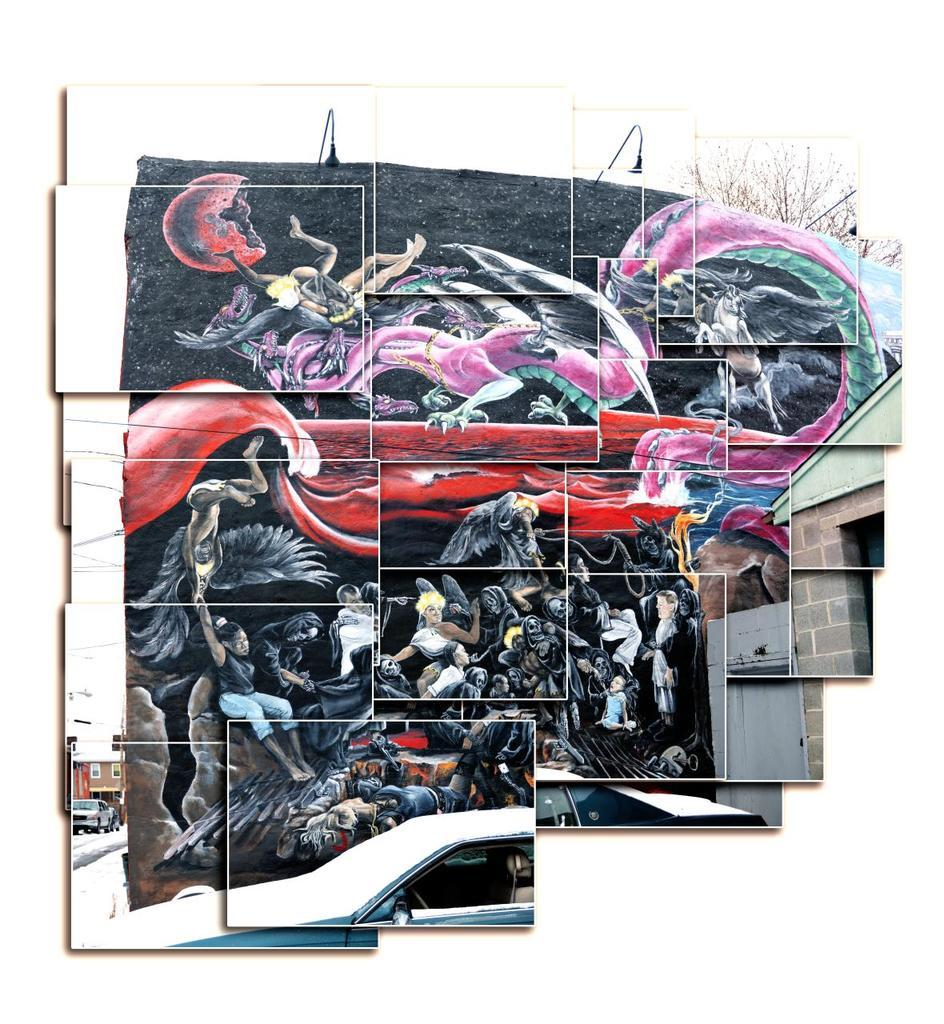What type of puzzle is depicted in the image? The image is a painting puzzle. What are the pieces of the puzzle made of? The painting puzzle contains cards. What suggestion does the painting puzzle give for running a marathon? The painting puzzle does not provide any suggestions for running a marathon, as it is a puzzle made of cards depicting a painting. 